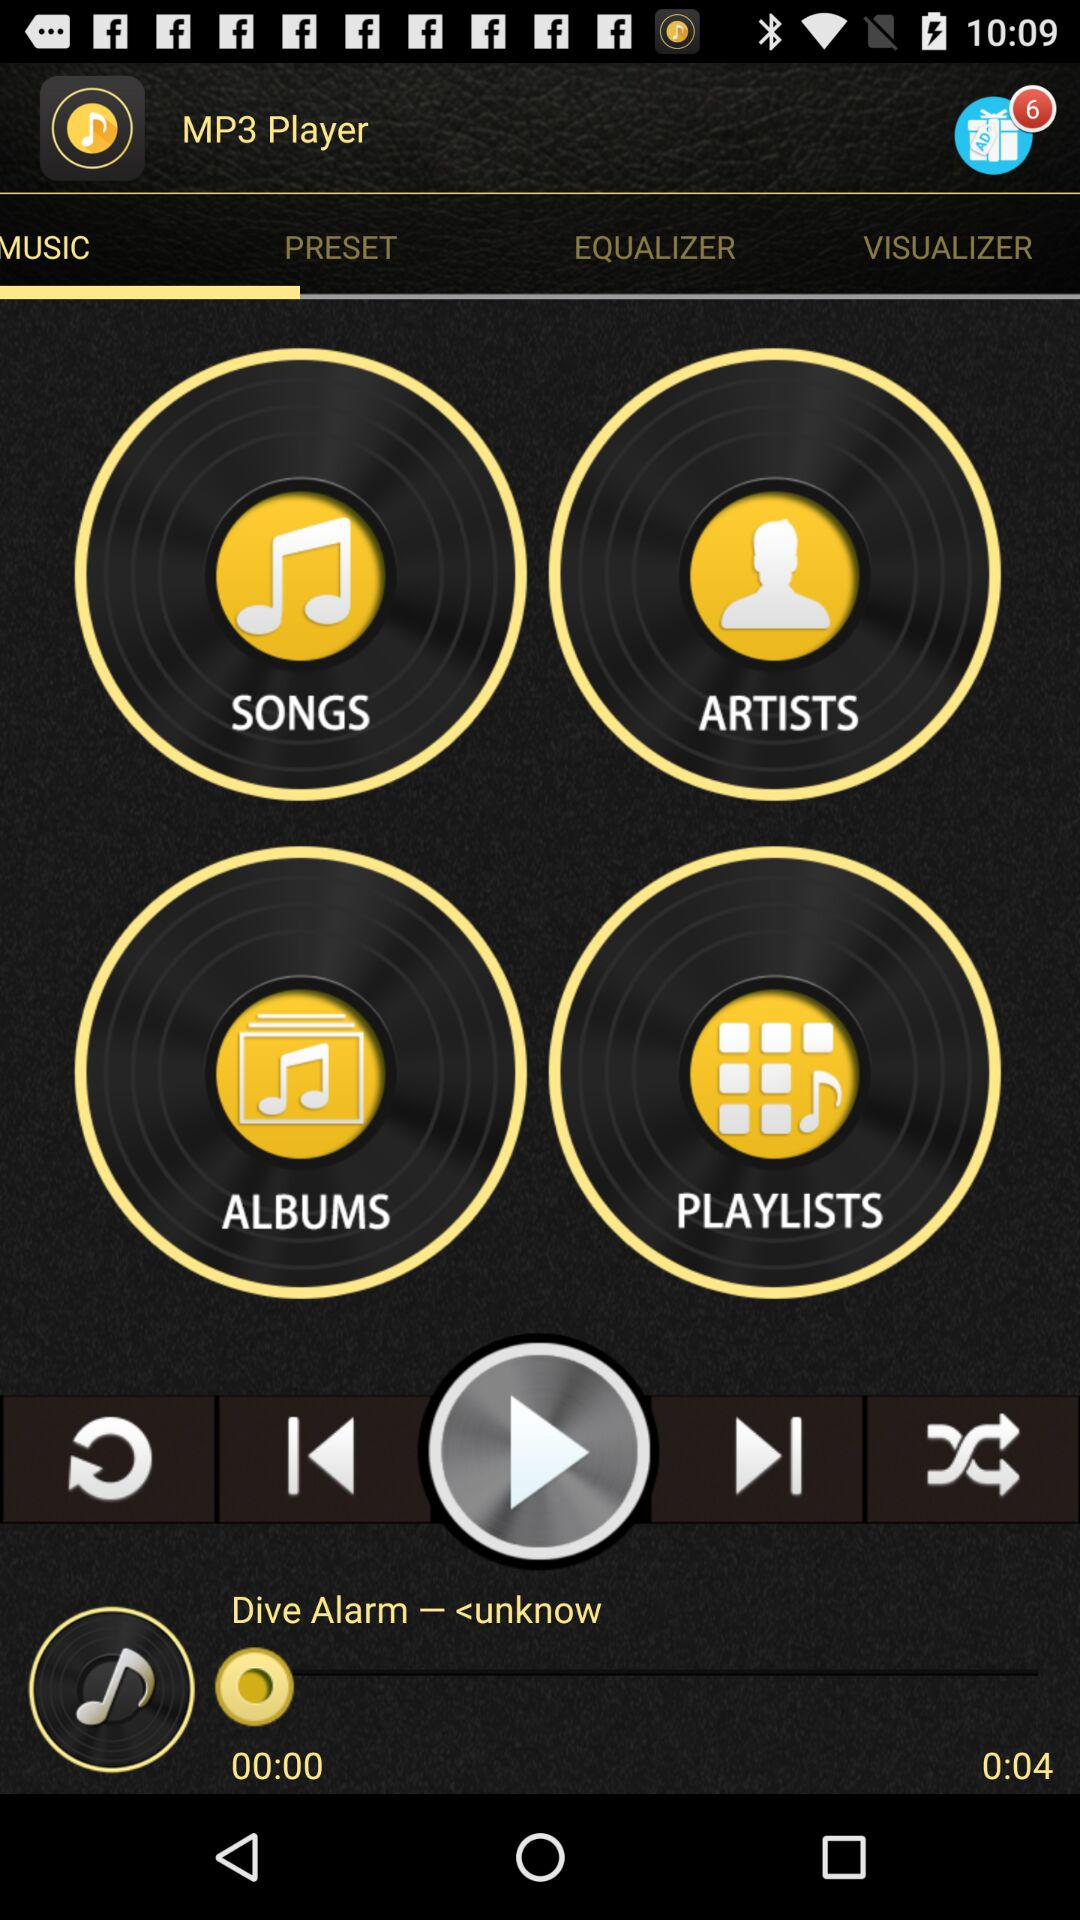What is the difference in time between the current time and the song length?
Answer the question using a single word or phrase. 0:04 